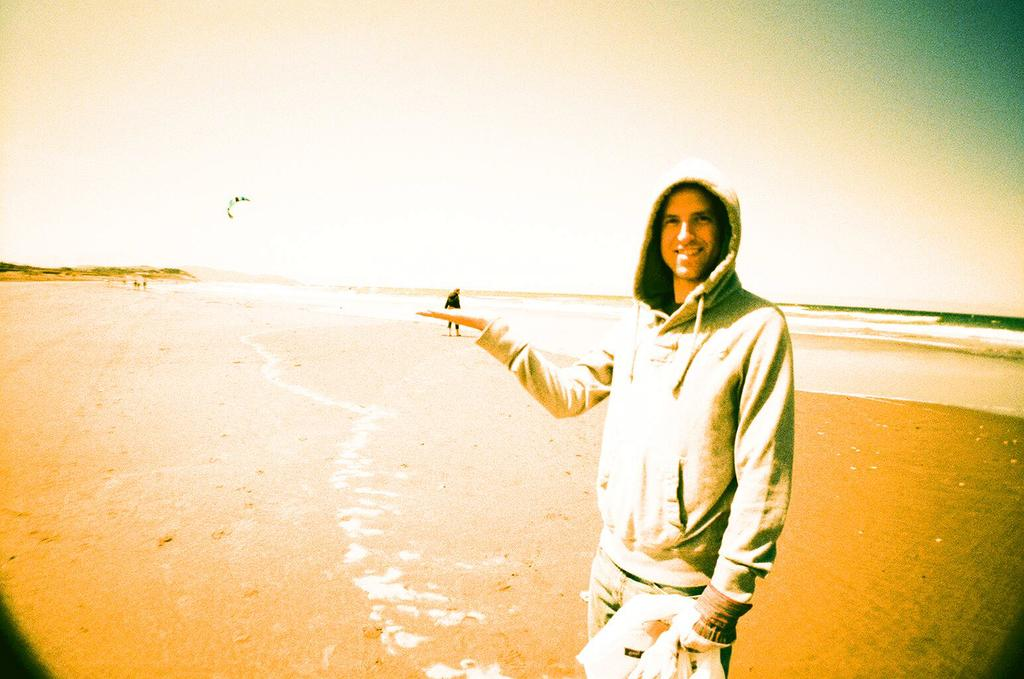Who is present in the image? There is a man standing in the image. Where is the man located? The man is near the beach. What type of terrain is visible at the bottom of the image? There is sand at the bottom of the image. What can be seen in the water in the background of the image? There are waves in the water in the background of the image. What is visible at the top of the image? The sky is visible at the top of the image. Can you tell me how many turkeys are visible in the image? There are no turkeys present in the image; it features a man standing near the beach. What type of swing can be seen in the image? There is no swing present in the image. 